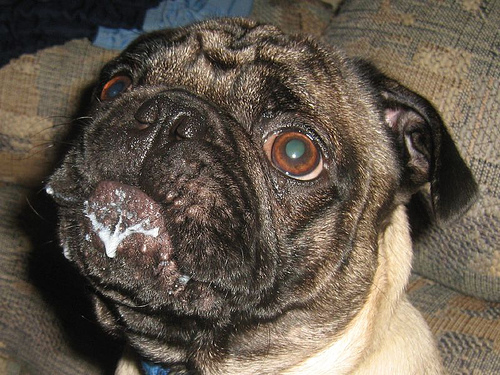<image>
Can you confirm if the drool is on the lip? Yes. Looking at the image, I can see the drool is positioned on top of the lip, with the lip providing support. 